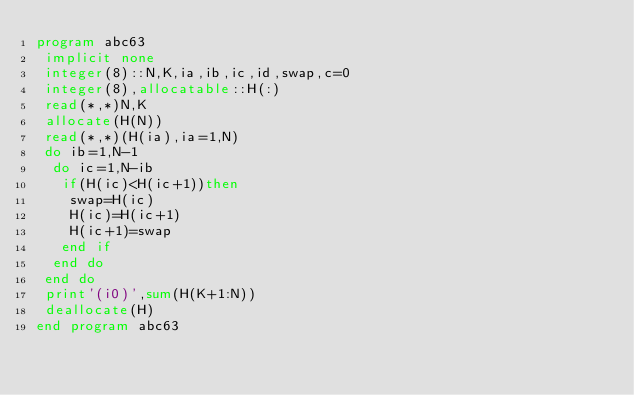Convert code to text. <code><loc_0><loc_0><loc_500><loc_500><_FORTRAN_>program abc63
 implicit none
 integer(8)::N,K,ia,ib,ic,id,swap,c=0
 integer(8),allocatable::H(:)
 read(*,*)N,K
 allocate(H(N))
 read(*,*)(H(ia),ia=1,N)
 do ib=1,N-1
  do ic=1,N-ib
   if(H(ic)<H(ic+1))then
    swap=H(ic)
    H(ic)=H(ic+1)
    H(ic+1)=swap
   end if
  end do
 end do
 print'(i0)',sum(H(K+1:N))
 deallocate(H)
end program abc63</code> 